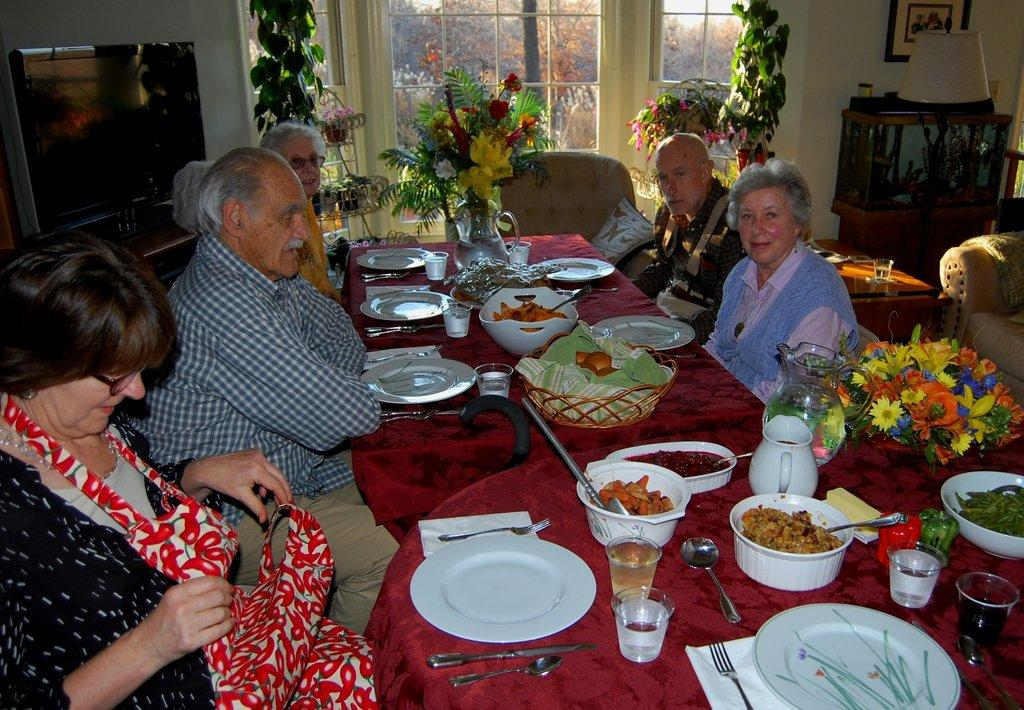Who is present in the image? There is a family in the image. Where are the family members located in the image? The family is sitting at a dining table. What activity are the family members about to engage in? The family is about to have their food. What statement does the doctor make about the family's health in the image? There is no doctor present in the image, and therefore no statement about the family's health can be made. 